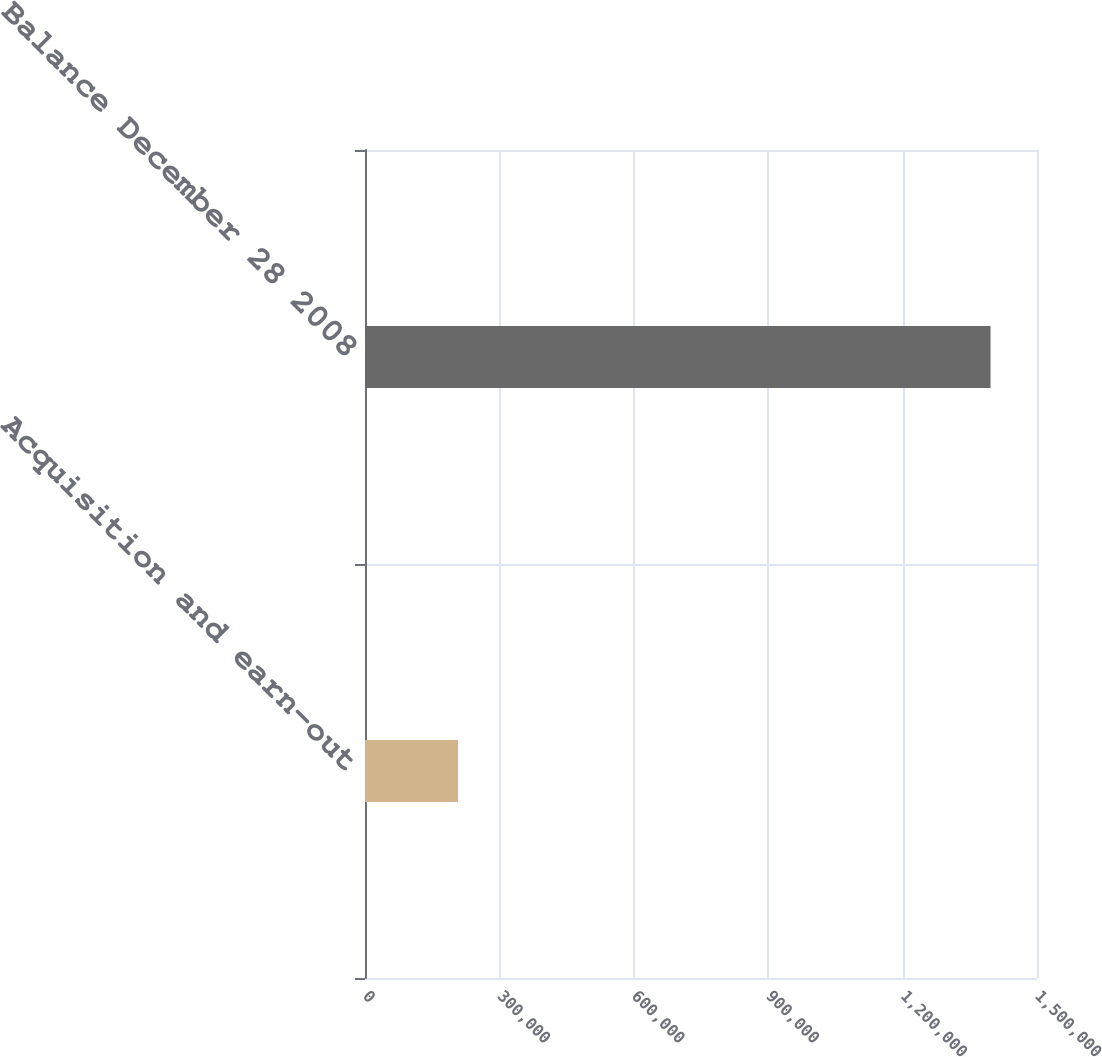Convert chart. <chart><loc_0><loc_0><loc_500><loc_500><bar_chart><fcel>Acquisition and earn-out<fcel>Balance December 28 2008<nl><fcel>207605<fcel>1.39629e+06<nl></chart> 